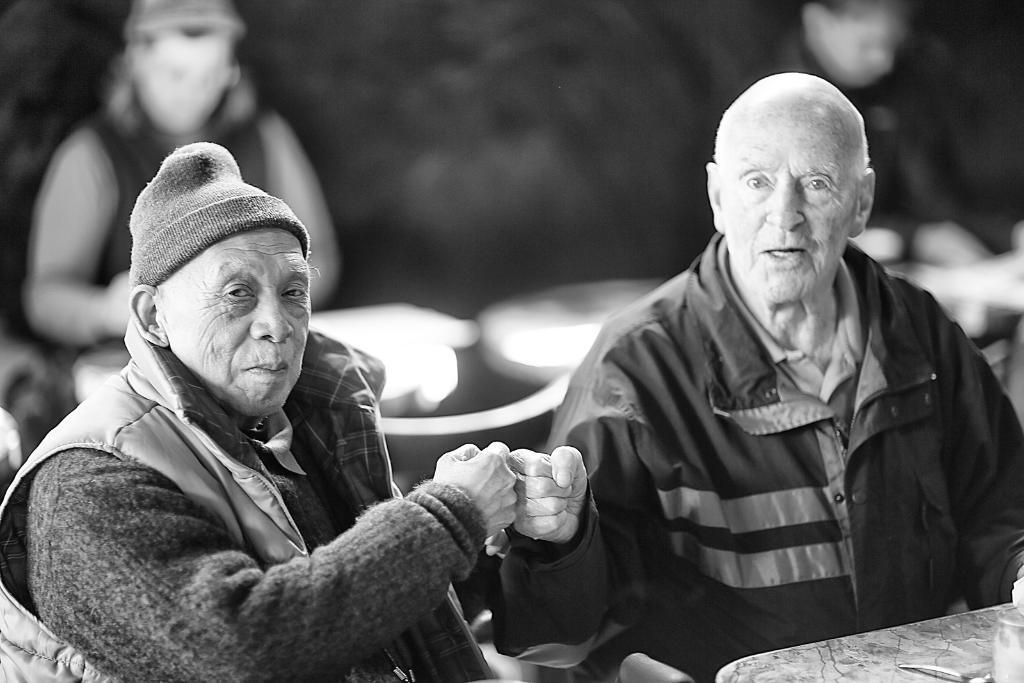Please provide a concise description of this image. This is a black and white picture, we can see a few people sitting on the chairs, there is a table with some objects and the background is blurred. 